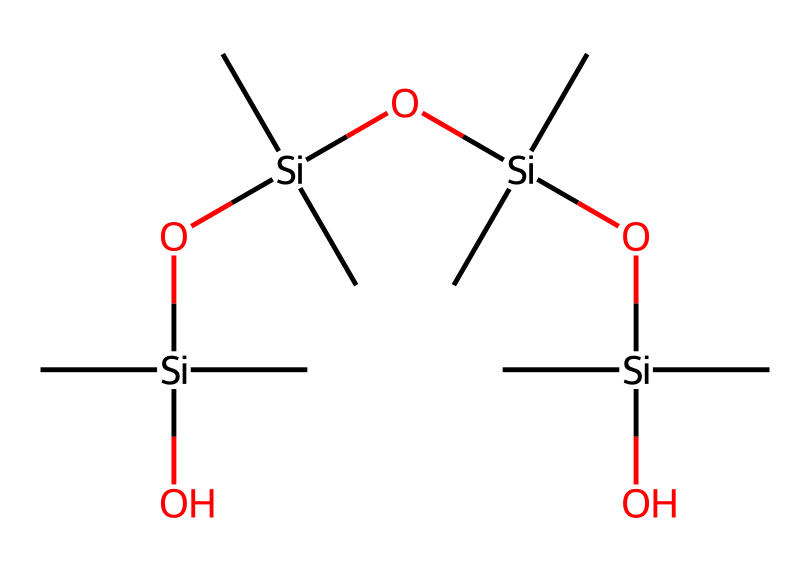How many silicon atoms are in the structure? By analyzing the SMILES representation, we can count the number of instances of the silicon atom symbol 'Si'. In the provided SMILES, 'Si' appears four times, corresponding to the four silicon atoms present in the polydimethylsiloxane structure.
Answer: four What type of bonds connect the silicon and oxygen atoms? In the SMILES, we see that the silicon atoms (Si) are connected to oxygen atoms (O) through single bonds, as indicated by the lack of a number following the elements and the overall structure. Therefore, the bond type is single bonds.
Answer: single bonds What functional groups are present in this compound? The presence of 'O' atoms connected to the silicon ('Si') indicates that there are silanol functional groups, specifically the -Si-OH groups. Additionally, the repeating units suggest that the compound mainly involves siloxane (-Si-O-Si-) chains.
Answer: silanol and siloxane What is the general property of polydimethylsiloxane that affects candy coatings? Polydimethylsiloxane is known for its low viscosity and excellent spreading properties, which allow it to form a smooth coating on candies, enhancing their appearance and texture. This property is derived from its long siloxane chains.
Answer: low viscosity How does the structure of this organosilicon compound contribute to the texture of candy? The long flexible siloxane chains in polydimethylsiloxane provide a unique ability to create a smooth, glossy, and uniform coating on candies, which enhances their mouthfeel and overall texture. This flexibility contributes to the desirable sensory experience of the candy.
Answer: smooth and glossy What is the primary purpose of polydimethylsiloxane in confectionery applications? Polydimethylsiloxane is primarily used as a food-grade silicone in confectionery to provide a protective barrier and improve the shelf-life of candies by preventing moisture loss and preventing sticking.
Answer: protective barrier 